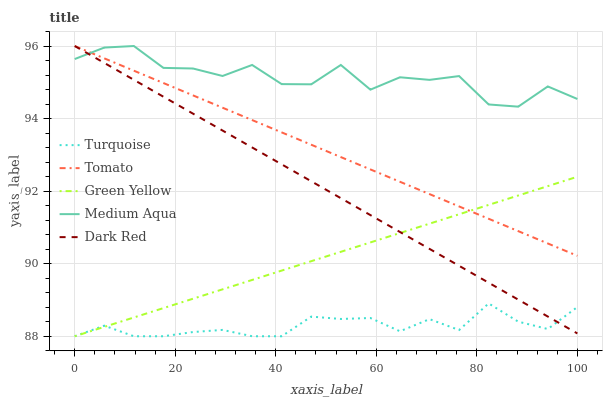Does Turquoise have the minimum area under the curve?
Answer yes or no. Yes. Does Medium Aqua have the maximum area under the curve?
Answer yes or no. Yes. Does Dark Red have the minimum area under the curve?
Answer yes or no. No. Does Dark Red have the maximum area under the curve?
Answer yes or no. No. Is Dark Red the smoothest?
Answer yes or no. Yes. Is Medium Aqua the roughest?
Answer yes or no. Yes. Is Turquoise the smoothest?
Answer yes or no. No. Is Turquoise the roughest?
Answer yes or no. No. Does Turquoise have the lowest value?
Answer yes or no. Yes. Does Dark Red have the lowest value?
Answer yes or no. No. Does Medium Aqua have the highest value?
Answer yes or no. Yes. Does Turquoise have the highest value?
Answer yes or no. No. Is Green Yellow less than Medium Aqua?
Answer yes or no. Yes. Is Tomato greater than Turquoise?
Answer yes or no. Yes. Does Tomato intersect Medium Aqua?
Answer yes or no. Yes. Is Tomato less than Medium Aqua?
Answer yes or no. No. Is Tomato greater than Medium Aqua?
Answer yes or no. No. Does Green Yellow intersect Medium Aqua?
Answer yes or no. No. 